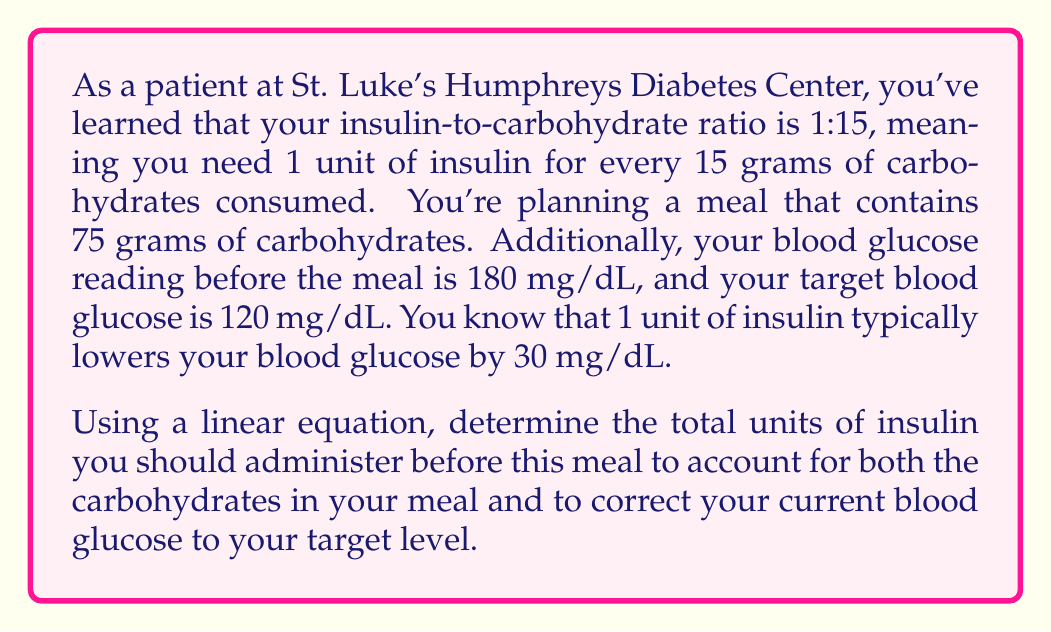Solve this math problem. Let's approach this problem step by step:

1. Calculate insulin needed for carbohydrates:
   - Carbohydrate intake = 75 grams
   - Insulin-to-carbohydrate ratio = 1:15
   - Insulin for carbs = $\frac{75}{15} = 5$ units

2. Calculate insulin needed for blood glucose correction:
   - Current blood glucose = 180 mg/dL
   - Target blood glucose = 120 mg/dL
   - Difference = 180 - 120 = 60 mg/dL
   - 1 unit of insulin lowers blood glucose by 30 mg/dL
   - Insulin for correction = $\frac{60}{30} = 2$ units

3. Set up a linear equation:
   Let $x$ be the total units of insulin needed.
   $$x = \text{Insulin for carbs} + \text{Insulin for correction}$$
   $$x = 5 + 2$$

4. Solve the equation:
   $$x = 7$$

Therefore, the total insulin dosage needed is 7 units.
Answer: 7 units of insulin 